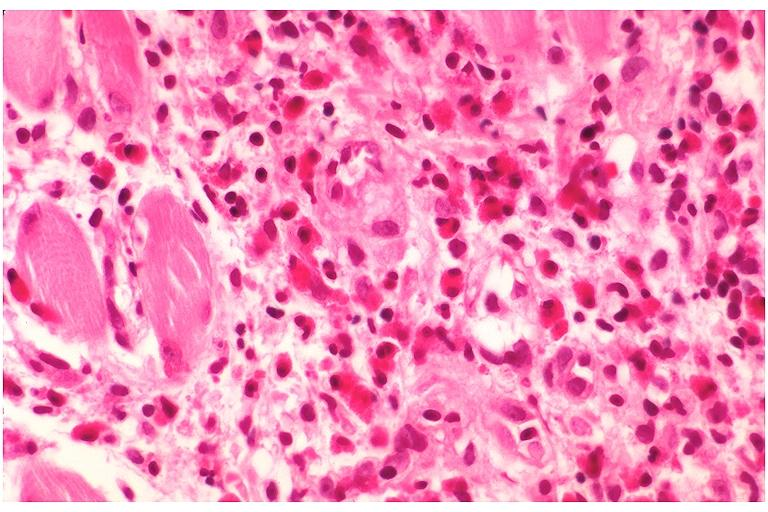what does this image show?
Answer the question using a single word or phrase. Langerhans cell histiocytosis eosinophilic granuloma 